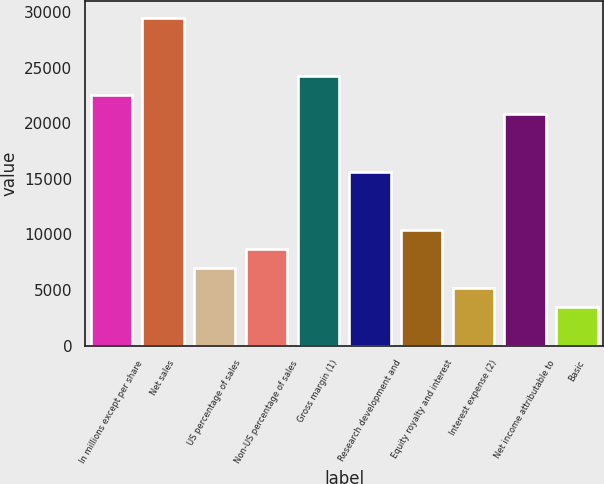Convert chart. <chart><loc_0><loc_0><loc_500><loc_500><bar_chart><fcel>In millions except per share<fcel>Net sales<fcel>US percentage of sales<fcel>Non-US percentage of sales<fcel>Gross margin (1)<fcel>Research development and<fcel>Equity royalty and interest<fcel>Interest expense (2)<fcel>Net income attributable to<fcel>Basic<nl><fcel>22533.7<fcel>29466.5<fcel>6934.68<fcel>8667.9<fcel>24266.9<fcel>15600.8<fcel>10401.1<fcel>5201.46<fcel>20800.4<fcel>3468.24<nl></chart> 